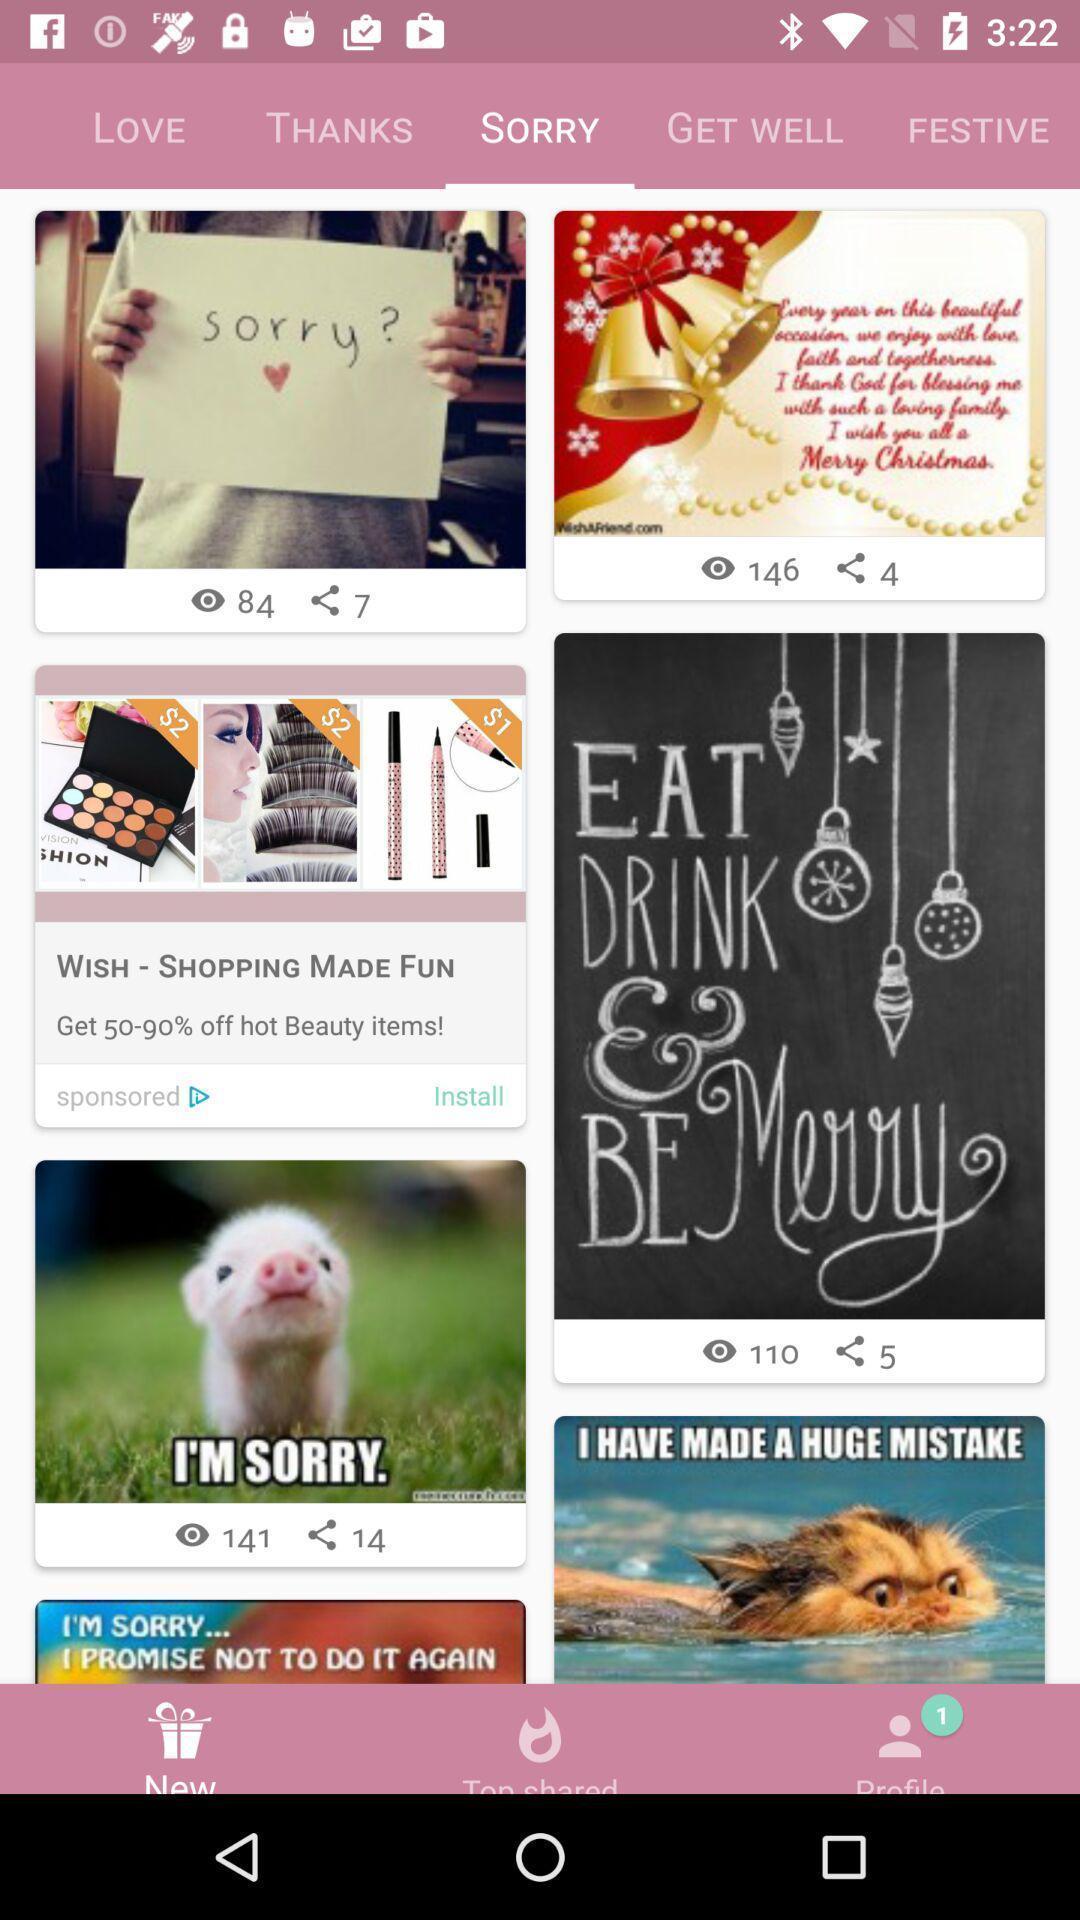What is the overall content of this screenshot? Screen showing various sorry images in social app. 